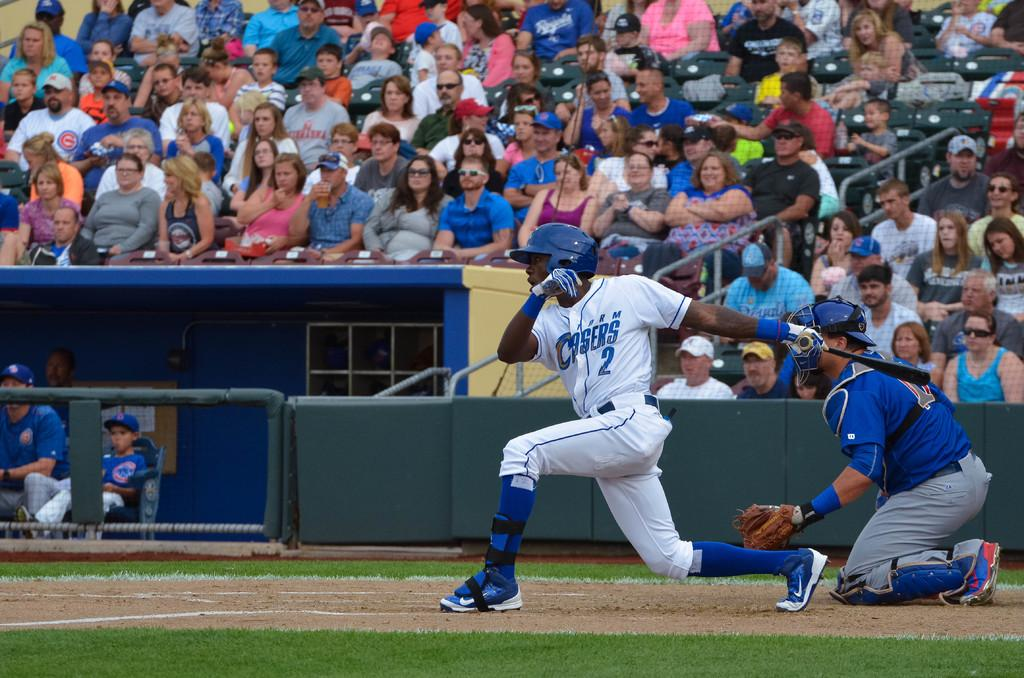<image>
Relay a brief, clear account of the picture shown. Player number 2 is about to toss the bat behind him and run toward first base. 